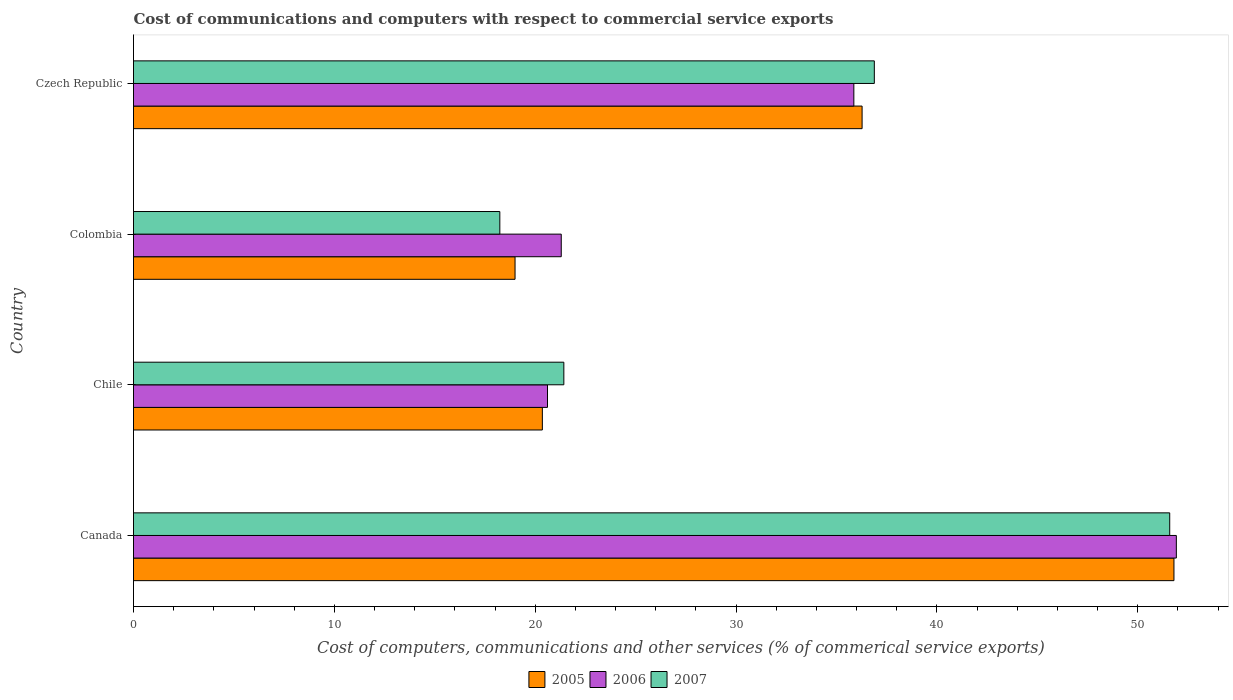How many different coloured bars are there?
Give a very brief answer. 3. How many groups of bars are there?
Ensure brevity in your answer.  4. Are the number of bars per tick equal to the number of legend labels?
Provide a succinct answer. Yes. How many bars are there on the 1st tick from the top?
Provide a short and direct response. 3. In how many cases, is the number of bars for a given country not equal to the number of legend labels?
Give a very brief answer. 0. What is the cost of communications and computers in 2005 in Czech Republic?
Offer a very short reply. 36.28. Across all countries, what is the maximum cost of communications and computers in 2007?
Your response must be concise. 51.6. Across all countries, what is the minimum cost of communications and computers in 2006?
Keep it short and to the point. 20.61. In which country was the cost of communications and computers in 2005 maximum?
Provide a succinct answer. Canada. In which country was the cost of communications and computers in 2006 minimum?
Provide a short and direct response. Chile. What is the total cost of communications and computers in 2006 in the graph?
Give a very brief answer. 129.71. What is the difference between the cost of communications and computers in 2005 in Colombia and that in Czech Republic?
Your answer should be very brief. -17.28. What is the difference between the cost of communications and computers in 2006 in Czech Republic and the cost of communications and computers in 2005 in Colombia?
Keep it short and to the point. 16.87. What is the average cost of communications and computers in 2006 per country?
Your answer should be compact. 32.43. What is the difference between the cost of communications and computers in 2005 and cost of communications and computers in 2006 in Czech Republic?
Your answer should be very brief. 0.41. What is the ratio of the cost of communications and computers in 2007 in Chile to that in Czech Republic?
Make the answer very short. 0.58. Is the cost of communications and computers in 2005 in Canada less than that in Colombia?
Your response must be concise. No. Is the difference between the cost of communications and computers in 2005 in Colombia and Czech Republic greater than the difference between the cost of communications and computers in 2006 in Colombia and Czech Republic?
Keep it short and to the point. No. What is the difference between the highest and the second highest cost of communications and computers in 2005?
Your response must be concise. 15.53. What is the difference between the highest and the lowest cost of communications and computers in 2007?
Offer a terse response. 33.36. In how many countries, is the cost of communications and computers in 2005 greater than the average cost of communications and computers in 2005 taken over all countries?
Your answer should be very brief. 2. Is the sum of the cost of communications and computers in 2007 in Chile and Czech Republic greater than the maximum cost of communications and computers in 2006 across all countries?
Provide a succinct answer. Yes. What does the 2nd bar from the top in Colombia represents?
Your response must be concise. 2006. What does the 1st bar from the bottom in Czech Republic represents?
Keep it short and to the point. 2005. How many bars are there?
Ensure brevity in your answer.  12. What is the difference between two consecutive major ticks on the X-axis?
Offer a very short reply. 10. Does the graph contain grids?
Offer a terse response. No. How many legend labels are there?
Give a very brief answer. 3. How are the legend labels stacked?
Ensure brevity in your answer.  Horizontal. What is the title of the graph?
Make the answer very short. Cost of communications and computers with respect to commercial service exports. What is the label or title of the X-axis?
Give a very brief answer. Cost of computers, communications and other services (% of commerical service exports). What is the Cost of computers, communications and other services (% of commerical service exports) in 2005 in Canada?
Provide a short and direct response. 51.81. What is the Cost of computers, communications and other services (% of commerical service exports) of 2006 in Canada?
Provide a succinct answer. 51.93. What is the Cost of computers, communications and other services (% of commerical service exports) of 2007 in Canada?
Make the answer very short. 51.6. What is the Cost of computers, communications and other services (% of commerical service exports) in 2005 in Chile?
Your response must be concise. 20.36. What is the Cost of computers, communications and other services (% of commerical service exports) of 2006 in Chile?
Offer a terse response. 20.61. What is the Cost of computers, communications and other services (% of commerical service exports) in 2007 in Chile?
Offer a terse response. 21.43. What is the Cost of computers, communications and other services (% of commerical service exports) in 2005 in Colombia?
Your response must be concise. 19. What is the Cost of computers, communications and other services (% of commerical service exports) of 2006 in Colombia?
Ensure brevity in your answer.  21.3. What is the Cost of computers, communications and other services (% of commerical service exports) in 2007 in Colombia?
Provide a succinct answer. 18.24. What is the Cost of computers, communications and other services (% of commerical service exports) of 2005 in Czech Republic?
Your answer should be very brief. 36.28. What is the Cost of computers, communications and other services (% of commerical service exports) in 2006 in Czech Republic?
Your response must be concise. 35.87. What is the Cost of computers, communications and other services (% of commerical service exports) of 2007 in Czech Republic?
Make the answer very short. 36.89. Across all countries, what is the maximum Cost of computers, communications and other services (% of commerical service exports) of 2005?
Make the answer very short. 51.81. Across all countries, what is the maximum Cost of computers, communications and other services (% of commerical service exports) in 2006?
Your answer should be compact. 51.93. Across all countries, what is the maximum Cost of computers, communications and other services (% of commerical service exports) of 2007?
Keep it short and to the point. 51.6. Across all countries, what is the minimum Cost of computers, communications and other services (% of commerical service exports) of 2005?
Your answer should be compact. 19. Across all countries, what is the minimum Cost of computers, communications and other services (% of commerical service exports) of 2006?
Offer a terse response. 20.61. Across all countries, what is the minimum Cost of computers, communications and other services (% of commerical service exports) in 2007?
Give a very brief answer. 18.24. What is the total Cost of computers, communications and other services (% of commerical service exports) of 2005 in the graph?
Provide a succinct answer. 127.44. What is the total Cost of computers, communications and other services (% of commerical service exports) in 2006 in the graph?
Make the answer very short. 129.71. What is the total Cost of computers, communications and other services (% of commerical service exports) in 2007 in the graph?
Your answer should be very brief. 128.15. What is the difference between the Cost of computers, communications and other services (% of commerical service exports) in 2005 in Canada and that in Chile?
Give a very brief answer. 31.45. What is the difference between the Cost of computers, communications and other services (% of commerical service exports) in 2006 in Canada and that in Chile?
Give a very brief answer. 31.31. What is the difference between the Cost of computers, communications and other services (% of commerical service exports) in 2007 in Canada and that in Chile?
Your response must be concise. 30.17. What is the difference between the Cost of computers, communications and other services (% of commerical service exports) in 2005 in Canada and that in Colombia?
Your response must be concise. 32.81. What is the difference between the Cost of computers, communications and other services (% of commerical service exports) in 2006 in Canada and that in Colombia?
Ensure brevity in your answer.  30.63. What is the difference between the Cost of computers, communications and other services (% of commerical service exports) in 2007 in Canada and that in Colombia?
Offer a terse response. 33.36. What is the difference between the Cost of computers, communications and other services (% of commerical service exports) in 2005 in Canada and that in Czech Republic?
Ensure brevity in your answer.  15.53. What is the difference between the Cost of computers, communications and other services (% of commerical service exports) in 2006 in Canada and that in Czech Republic?
Keep it short and to the point. 16.06. What is the difference between the Cost of computers, communications and other services (% of commerical service exports) in 2007 in Canada and that in Czech Republic?
Your response must be concise. 14.71. What is the difference between the Cost of computers, communications and other services (% of commerical service exports) of 2005 in Chile and that in Colombia?
Your response must be concise. 1.36. What is the difference between the Cost of computers, communications and other services (% of commerical service exports) in 2006 in Chile and that in Colombia?
Ensure brevity in your answer.  -0.69. What is the difference between the Cost of computers, communications and other services (% of commerical service exports) in 2007 in Chile and that in Colombia?
Provide a succinct answer. 3.19. What is the difference between the Cost of computers, communications and other services (% of commerical service exports) of 2005 in Chile and that in Czech Republic?
Offer a very short reply. -15.92. What is the difference between the Cost of computers, communications and other services (% of commerical service exports) of 2006 in Chile and that in Czech Republic?
Your answer should be very brief. -15.25. What is the difference between the Cost of computers, communications and other services (% of commerical service exports) of 2007 in Chile and that in Czech Republic?
Your response must be concise. -15.46. What is the difference between the Cost of computers, communications and other services (% of commerical service exports) in 2005 in Colombia and that in Czech Republic?
Your answer should be very brief. -17.28. What is the difference between the Cost of computers, communications and other services (% of commerical service exports) in 2006 in Colombia and that in Czech Republic?
Make the answer very short. -14.57. What is the difference between the Cost of computers, communications and other services (% of commerical service exports) of 2007 in Colombia and that in Czech Republic?
Keep it short and to the point. -18.65. What is the difference between the Cost of computers, communications and other services (% of commerical service exports) in 2005 in Canada and the Cost of computers, communications and other services (% of commerical service exports) in 2006 in Chile?
Ensure brevity in your answer.  31.19. What is the difference between the Cost of computers, communications and other services (% of commerical service exports) of 2005 in Canada and the Cost of computers, communications and other services (% of commerical service exports) of 2007 in Chile?
Your response must be concise. 30.38. What is the difference between the Cost of computers, communications and other services (% of commerical service exports) in 2006 in Canada and the Cost of computers, communications and other services (% of commerical service exports) in 2007 in Chile?
Keep it short and to the point. 30.5. What is the difference between the Cost of computers, communications and other services (% of commerical service exports) of 2005 in Canada and the Cost of computers, communications and other services (% of commerical service exports) of 2006 in Colombia?
Keep it short and to the point. 30.51. What is the difference between the Cost of computers, communications and other services (% of commerical service exports) in 2005 in Canada and the Cost of computers, communications and other services (% of commerical service exports) in 2007 in Colombia?
Keep it short and to the point. 33.57. What is the difference between the Cost of computers, communications and other services (% of commerical service exports) of 2006 in Canada and the Cost of computers, communications and other services (% of commerical service exports) of 2007 in Colombia?
Your answer should be compact. 33.69. What is the difference between the Cost of computers, communications and other services (% of commerical service exports) of 2005 in Canada and the Cost of computers, communications and other services (% of commerical service exports) of 2006 in Czech Republic?
Provide a succinct answer. 15.94. What is the difference between the Cost of computers, communications and other services (% of commerical service exports) of 2005 in Canada and the Cost of computers, communications and other services (% of commerical service exports) of 2007 in Czech Republic?
Keep it short and to the point. 14.92. What is the difference between the Cost of computers, communications and other services (% of commerical service exports) of 2006 in Canada and the Cost of computers, communications and other services (% of commerical service exports) of 2007 in Czech Republic?
Keep it short and to the point. 15.04. What is the difference between the Cost of computers, communications and other services (% of commerical service exports) of 2005 in Chile and the Cost of computers, communications and other services (% of commerical service exports) of 2006 in Colombia?
Offer a very short reply. -0.94. What is the difference between the Cost of computers, communications and other services (% of commerical service exports) in 2005 in Chile and the Cost of computers, communications and other services (% of commerical service exports) in 2007 in Colombia?
Your answer should be compact. 2.12. What is the difference between the Cost of computers, communications and other services (% of commerical service exports) of 2006 in Chile and the Cost of computers, communications and other services (% of commerical service exports) of 2007 in Colombia?
Offer a very short reply. 2.37. What is the difference between the Cost of computers, communications and other services (% of commerical service exports) of 2005 in Chile and the Cost of computers, communications and other services (% of commerical service exports) of 2006 in Czech Republic?
Your answer should be very brief. -15.51. What is the difference between the Cost of computers, communications and other services (% of commerical service exports) in 2005 in Chile and the Cost of computers, communications and other services (% of commerical service exports) in 2007 in Czech Republic?
Your answer should be very brief. -16.53. What is the difference between the Cost of computers, communications and other services (% of commerical service exports) of 2006 in Chile and the Cost of computers, communications and other services (% of commerical service exports) of 2007 in Czech Republic?
Provide a succinct answer. -16.27. What is the difference between the Cost of computers, communications and other services (% of commerical service exports) in 2005 in Colombia and the Cost of computers, communications and other services (% of commerical service exports) in 2006 in Czech Republic?
Your answer should be compact. -16.87. What is the difference between the Cost of computers, communications and other services (% of commerical service exports) in 2005 in Colombia and the Cost of computers, communications and other services (% of commerical service exports) in 2007 in Czech Republic?
Give a very brief answer. -17.89. What is the difference between the Cost of computers, communications and other services (% of commerical service exports) of 2006 in Colombia and the Cost of computers, communications and other services (% of commerical service exports) of 2007 in Czech Republic?
Provide a succinct answer. -15.59. What is the average Cost of computers, communications and other services (% of commerical service exports) of 2005 per country?
Your answer should be very brief. 31.86. What is the average Cost of computers, communications and other services (% of commerical service exports) in 2006 per country?
Offer a terse response. 32.43. What is the average Cost of computers, communications and other services (% of commerical service exports) in 2007 per country?
Provide a short and direct response. 32.04. What is the difference between the Cost of computers, communications and other services (% of commerical service exports) in 2005 and Cost of computers, communications and other services (% of commerical service exports) in 2006 in Canada?
Offer a terse response. -0.12. What is the difference between the Cost of computers, communications and other services (% of commerical service exports) of 2005 and Cost of computers, communications and other services (% of commerical service exports) of 2007 in Canada?
Keep it short and to the point. 0.21. What is the difference between the Cost of computers, communications and other services (% of commerical service exports) of 2006 and Cost of computers, communications and other services (% of commerical service exports) of 2007 in Canada?
Give a very brief answer. 0.33. What is the difference between the Cost of computers, communications and other services (% of commerical service exports) of 2005 and Cost of computers, communications and other services (% of commerical service exports) of 2006 in Chile?
Offer a terse response. -0.26. What is the difference between the Cost of computers, communications and other services (% of commerical service exports) in 2005 and Cost of computers, communications and other services (% of commerical service exports) in 2007 in Chile?
Offer a very short reply. -1.07. What is the difference between the Cost of computers, communications and other services (% of commerical service exports) of 2006 and Cost of computers, communications and other services (% of commerical service exports) of 2007 in Chile?
Your answer should be very brief. -0.81. What is the difference between the Cost of computers, communications and other services (% of commerical service exports) in 2005 and Cost of computers, communications and other services (% of commerical service exports) in 2006 in Colombia?
Keep it short and to the point. -2.3. What is the difference between the Cost of computers, communications and other services (% of commerical service exports) of 2005 and Cost of computers, communications and other services (% of commerical service exports) of 2007 in Colombia?
Give a very brief answer. 0.76. What is the difference between the Cost of computers, communications and other services (% of commerical service exports) of 2006 and Cost of computers, communications and other services (% of commerical service exports) of 2007 in Colombia?
Ensure brevity in your answer.  3.06. What is the difference between the Cost of computers, communications and other services (% of commerical service exports) in 2005 and Cost of computers, communications and other services (% of commerical service exports) in 2006 in Czech Republic?
Your response must be concise. 0.41. What is the difference between the Cost of computers, communications and other services (% of commerical service exports) of 2005 and Cost of computers, communications and other services (% of commerical service exports) of 2007 in Czech Republic?
Make the answer very short. -0.61. What is the difference between the Cost of computers, communications and other services (% of commerical service exports) in 2006 and Cost of computers, communications and other services (% of commerical service exports) in 2007 in Czech Republic?
Ensure brevity in your answer.  -1.02. What is the ratio of the Cost of computers, communications and other services (% of commerical service exports) in 2005 in Canada to that in Chile?
Your response must be concise. 2.54. What is the ratio of the Cost of computers, communications and other services (% of commerical service exports) in 2006 in Canada to that in Chile?
Give a very brief answer. 2.52. What is the ratio of the Cost of computers, communications and other services (% of commerical service exports) in 2007 in Canada to that in Chile?
Provide a short and direct response. 2.41. What is the ratio of the Cost of computers, communications and other services (% of commerical service exports) in 2005 in Canada to that in Colombia?
Your answer should be compact. 2.73. What is the ratio of the Cost of computers, communications and other services (% of commerical service exports) in 2006 in Canada to that in Colombia?
Your response must be concise. 2.44. What is the ratio of the Cost of computers, communications and other services (% of commerical service exports) of 2007 in Canada to that in Colombia?
Your response must be concise. 2.83. What is the ratio of the Cost of computers, communications and other services (% of commerical service exports) in 2005 in Canada to that in Czech Republic?
Give a very brief answer. 1.43. What is the ratio of the Cost of computers, communications and other services (% of commerical service exports) of 2006 in Canada to that in Czech Republic?
Your answer should be compact. 1.45. What is the ratio of the Cost of computers, communications and other services (% of commerical service exports) in 2007 in Canada to that in Czech Republic?
Offer a terse response. 1.4. What is the ratio of the Cost of computers, communications and other services (% of commerical service exports) in 2005 in Chile to that in Colombia?
Your answer should be compact. 1.07. What is the ratio of the Cost of computers, communications and other services (% of commerical service exports) in 2006 in Chile to that in Colombia?
Your answer should be compact. 0.97. What is the ratio of the Cost of computers, communications and other services (% of commerical service exports) of 2007 in Chile to that in Colombia?
Ensure brevity in your answer.  1.17. What is the ratio of the Cost of computers, communications and other services (% of commerical service exports) of 2005 in Chile to that in Czech Republic?
Make the answer very short. 0.56. What is the ratio of the Cost of computers, communications and other services (% of commerical service exports) in 2006 in Chile to that in Czech Republic?
Provide a short and direct response. 0.57. What is the ratio of the Cost of computers, communications and other services (% of commerical service exports) of 2007 in Chile to that in Czech Republic?
Ensure brevity in your answer.  0.58. What is the ratio of the Cost of computers, communications and other services (% of commerical service exports) in 2005 in Colombia to that in Czech Republic?
Keep it short and to the point. 0.52. What is the ratio of the Cost of computers, communications and other services (% of commerical service exports) in 2006 in Colombia to that in Czech Republic?
Your answer should be very brief. 0.59. What is the ratio of the Cost of computers, communications and other services (% of commerical service exports) in 2007 in Colombia to that in Czech Republic?
Your response must be concise. 0.49. What is the difference between the highest and the second highest Cost of computers, communications and other services (% of commerical service exports) in 2005?
Keep it short and to the point. 15.53. What is the difference between the highest and the second highest Cost of computers, communications and other services (% of commerical service exports) of 2006?
Your response must be concise. 16.06. What is the difference between the highest and the second highest Cost of computers, communications and other services (% of commerical service exports) of 2007?
Offer a terse response. 14.71. What is the difference between the highest and the lowest Cost of computers, communications and other services (% of commerical service exports) of 2005?
Offer a terse response. 32.81. What is the difference between the highest and the lowest Cost of computers, communications and other services (% of commerical service exports) in 2006?
Provide a short and direct response. 31.31. What is the difference between the highest and the lowest Cost of computers, communications and other services (% of commerical service exports) of 2007?
Keep it short and to the point. 33.36. 